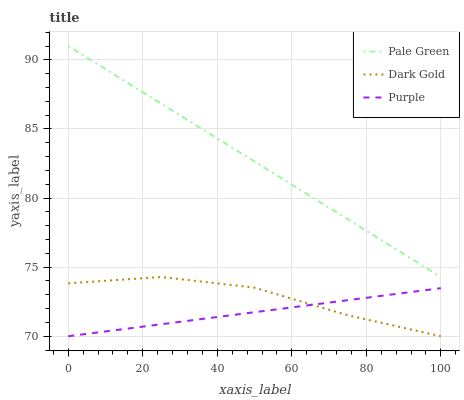Does Dark Gold have the minimum area under the curve?
Answer yes or no. No. Does Dark Gold have the maximum area under the curve?
Answer yes or no. No. Is Dark Gold the smoothest?
Answer yes or no. No. Is Pale Green the roughest?
Answer yes or no. No. Does Pale Green have the lowest value?
Answer yes or no. No. Does Dark Gold have the highest value?
Answer yes or no. No. Is Dark Gold less than Pale Green?
Answer yes or no. Yes. Is Pale Green greater than Dark Gold?
Answer yes or no. Yes. Does Dark Gold intersect Pale Green?
Answer yes or no. No. 